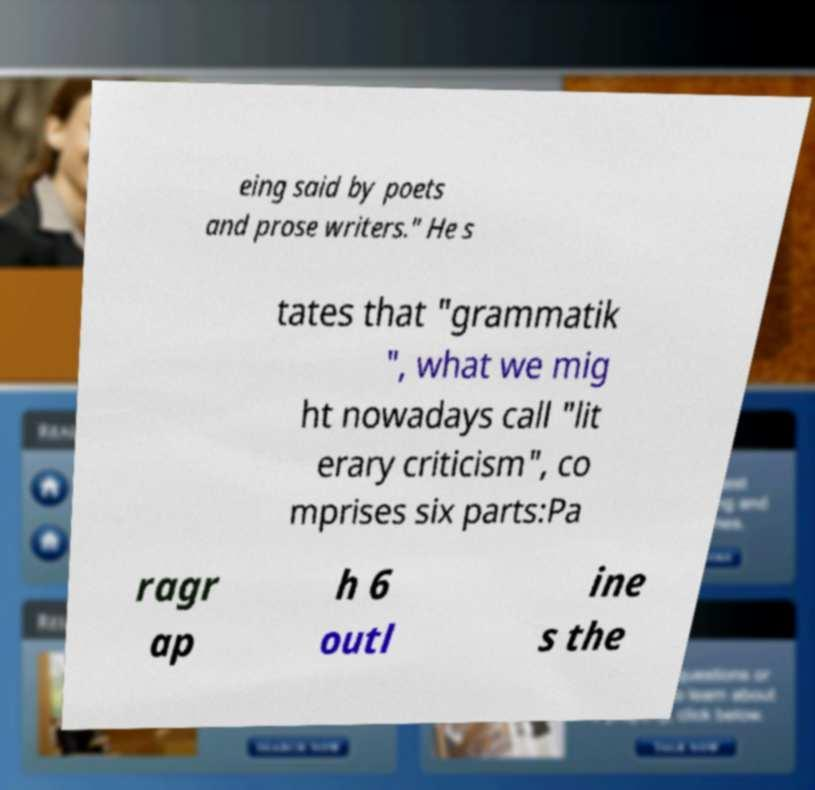What messages or text are displayed in this image? I need them in a readable, typed format. eing said by poets and prose writers." He s tates that "grammatik ", what we mig ht nowadays call "lit erary criticism", co mprises six parts:Pa ragr ap h 6 outl ine s the 